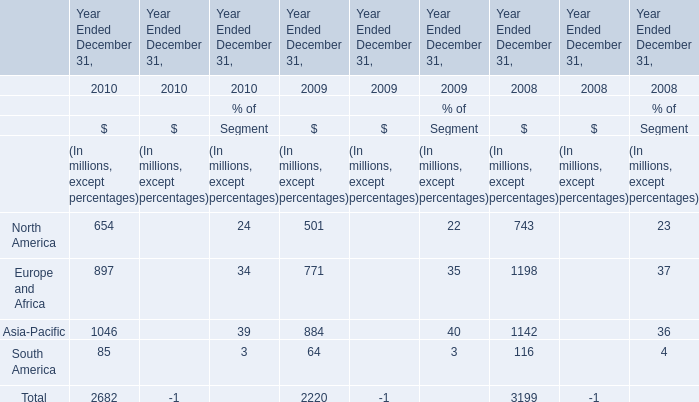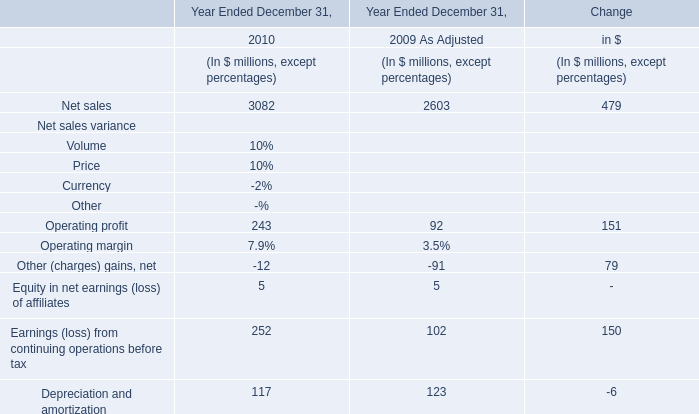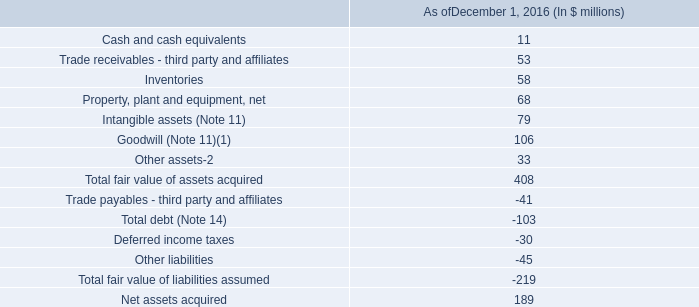What was the average value of the Europe and Africa and Asia-Pacific in the years where North America is positive? (in million) 
Computations: ((1198 + 1142) / 2)
Answer: 1170.0. What's the total amount of the North America and Europe and Africa in the years where Net sales is greater than 3000? (in million) 
Computations: (654 + 897)
Answer: 1551.0. 